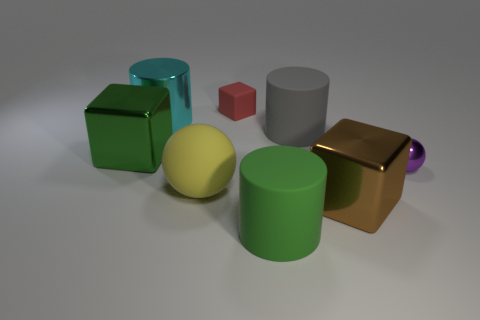Add 2 shiny spheres. How many objects exist? 10 Subtract all blocks. How many objects are left? 5 Add 6 green objects. How many green objects are left? 8 Add 6 big blue balls. How many big blue balls exist? 6 Subtract 1 green cubes. How many objects are left? 7 Subtract all large green objects. Subtract all small red cubes. How many objects are left? 5 